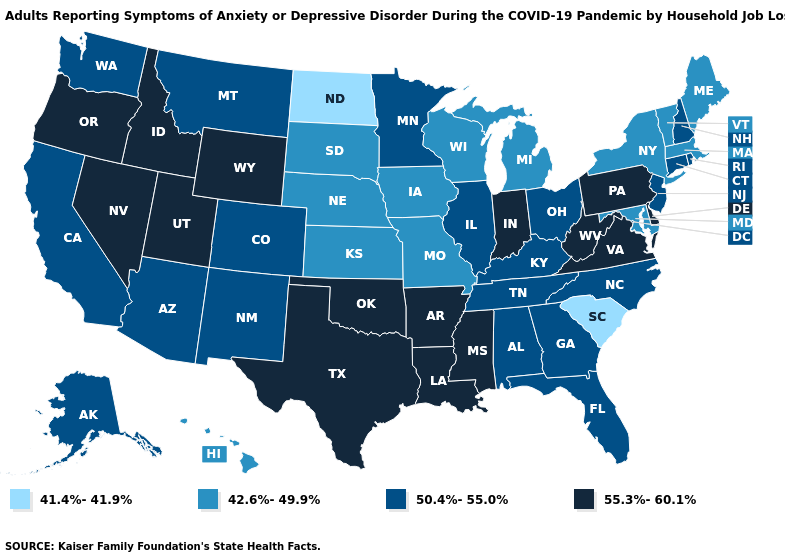Name the states that have a value in the range 41.4%-41.9%?
Be succinct. North Dakota, South Carolina. Does Hawaii have the lowest value in the West?
Concise answer only. Yes. Among the states that border Kentucky , does Tennessee have the highest value?
Quick response, please. No. What is the lowest value in the USA?
Concise answer only. 41.4%-41.9%. Name the states that have a value in the range 50.4%-55.0%?
Keep it brief. Alabama, Alaska, Arizona, California, Colorado, Connecticut, Florida, Georgia, Illinois, Kentucky, Minnesota, Montana, New Hampshire, New Jersey, New Mexico, North Carolina, Ohio, Rhode Island, Tennessee, Washington. What is the value of North Dakota?
Concise answer only. 41.4%-41.9%. What is the value of Delaware?
Concise answer only. 55.3%-60.1%. Does Oregon have the highest value in the West?
Be succinct. Yes. Which states have the highest value in the USA?
Be succinct. Arkansas, Delaware, Idaho, Indiana, Louisiana, Mississippi, Nevada, Oklahoma, Oregon, Pennsylvania, Texas, Utah, Virginia, West Virginia, Wyoming. Name the states that have a value in the range 50.4%-55.0%?
Answer briefly. Alabama, Alaska, Arizona, California, Colorado, Connecticut, Florida, Georgia, Illinois, Kentucky, Minnesota, Montana, New Hampshire, New Jersey, New Mexico, North Carolina, Ohio, Rhode Island, Tennessee, Washington. What is the value of West Virginia?
Answer briefly. 55.3%-60.1%. Does Missouri have the same value as Maryland?
Give a very brief answer. Yes. Name the states that have a value in the range 42.6%-49.9%?
Short answer required. Hawaii, Iowa, Kansas, Maine, Maryland, Massachusetts, Michigan, Missouri, Nebraska, New York, South Dakota, Vermont, Wisconsin. Name the states that have a value in the range 42.6%-49.9%?
Quick response, please. Hawaii, Iowa, Kansas, Maine, Maryland, Massachusetts, Michigan, Missouri, Nebraska, New York, South Dakota, Vermont, Wisconsin. Which states have the lowest value in the USA?
Short answer required. North Dakota, South Carolina. 